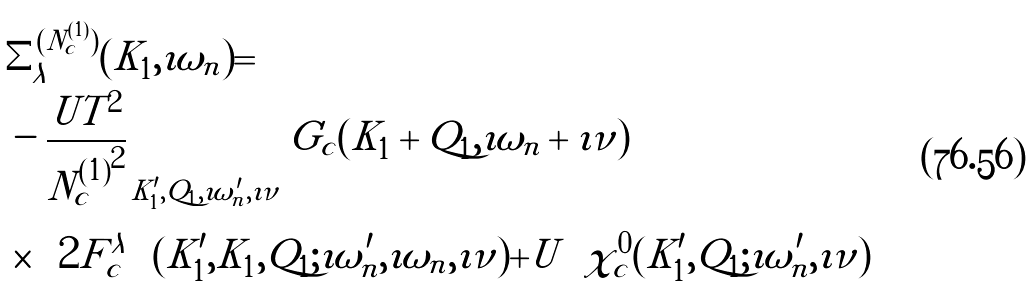<formula> <loc_0><loc_0><loc_500><loc_500>& \Sigma ^ { ( N _ { c } ^ { ( 1 ) } ) } _ { \lambda } ( K _ { 1 } , \imath \omega _ { n } ) = \\ & - \frac { U T ^ { 2 } } { { N _ { c } ^ { ( 1 ) } } ^ { 2 } } \sum _ { K ^ { \prime } _ { 1 } , Q _ { 1 } , \imath \omega _ { n } ^ { \prime } , \imath \nu } G _ { c } ( K _ { 1 } + Q _ { 1 } , \imath \omega _ { n } + \imath \nu ) \\ & \times \left ( 2 F ^ { \lambda \uparrow \downarrow } _ { c } ( K ^ { \prime } _ { 1 } , K _ { 1 } , Q _ { 1 } ; \imath \omega _ { n } ^ { \prime } , \imath \omega _ { n } , \imath \nu ) + U \right ) \chi ^ { 0 } _ { c } ( K ^ { \prime } _ { 1 } , Q _ { 1 } ; \imath \omega _ { n } ^ { \prime } , \imath \nu )</formula> 